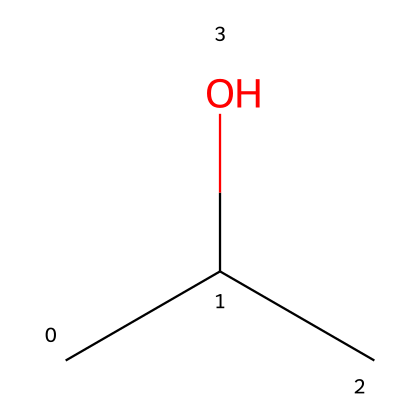What is the common name of this chemical? The SMILES representation CC(C)O corresponds to isopropyl alcohol, which is a common name for the compound C3H8O.
Answer: isopropyl alcohol How many carbon atoms are in this structure? The SMILES notation shows three 'C' which indicates there are three carbon atoms in the molecule.
Answer: three What type of functional group does isopropyl alcohol have? The structure contains a hydroxyl group (-OH) attached to a carbon, indicating it is an alcohol.
Answer: alcohol What is the number of hydrogen atoms in this molecule? Each carbon in the structure (3 carbons) typically bonds to enough hydrogen atoms to fulfill carbon's tetravalency. In the case of isopropyl alcohol, the total is 8 hydrogen atoms.
Answer: eight Is isopropyl alcohol considered flammable? The properties of isopropyl alcohol indicate that it has a flash point below 100 degrees Fahrenheit, confirming it is flammable.
Answer: yes What is the boiling point range for isopropyl alcohol? Isopropyl alcohol has a boiling point of approximately 82.6 degrees Celsius based on its chemical structure.
Answer: 82.6 degrees Celsius 